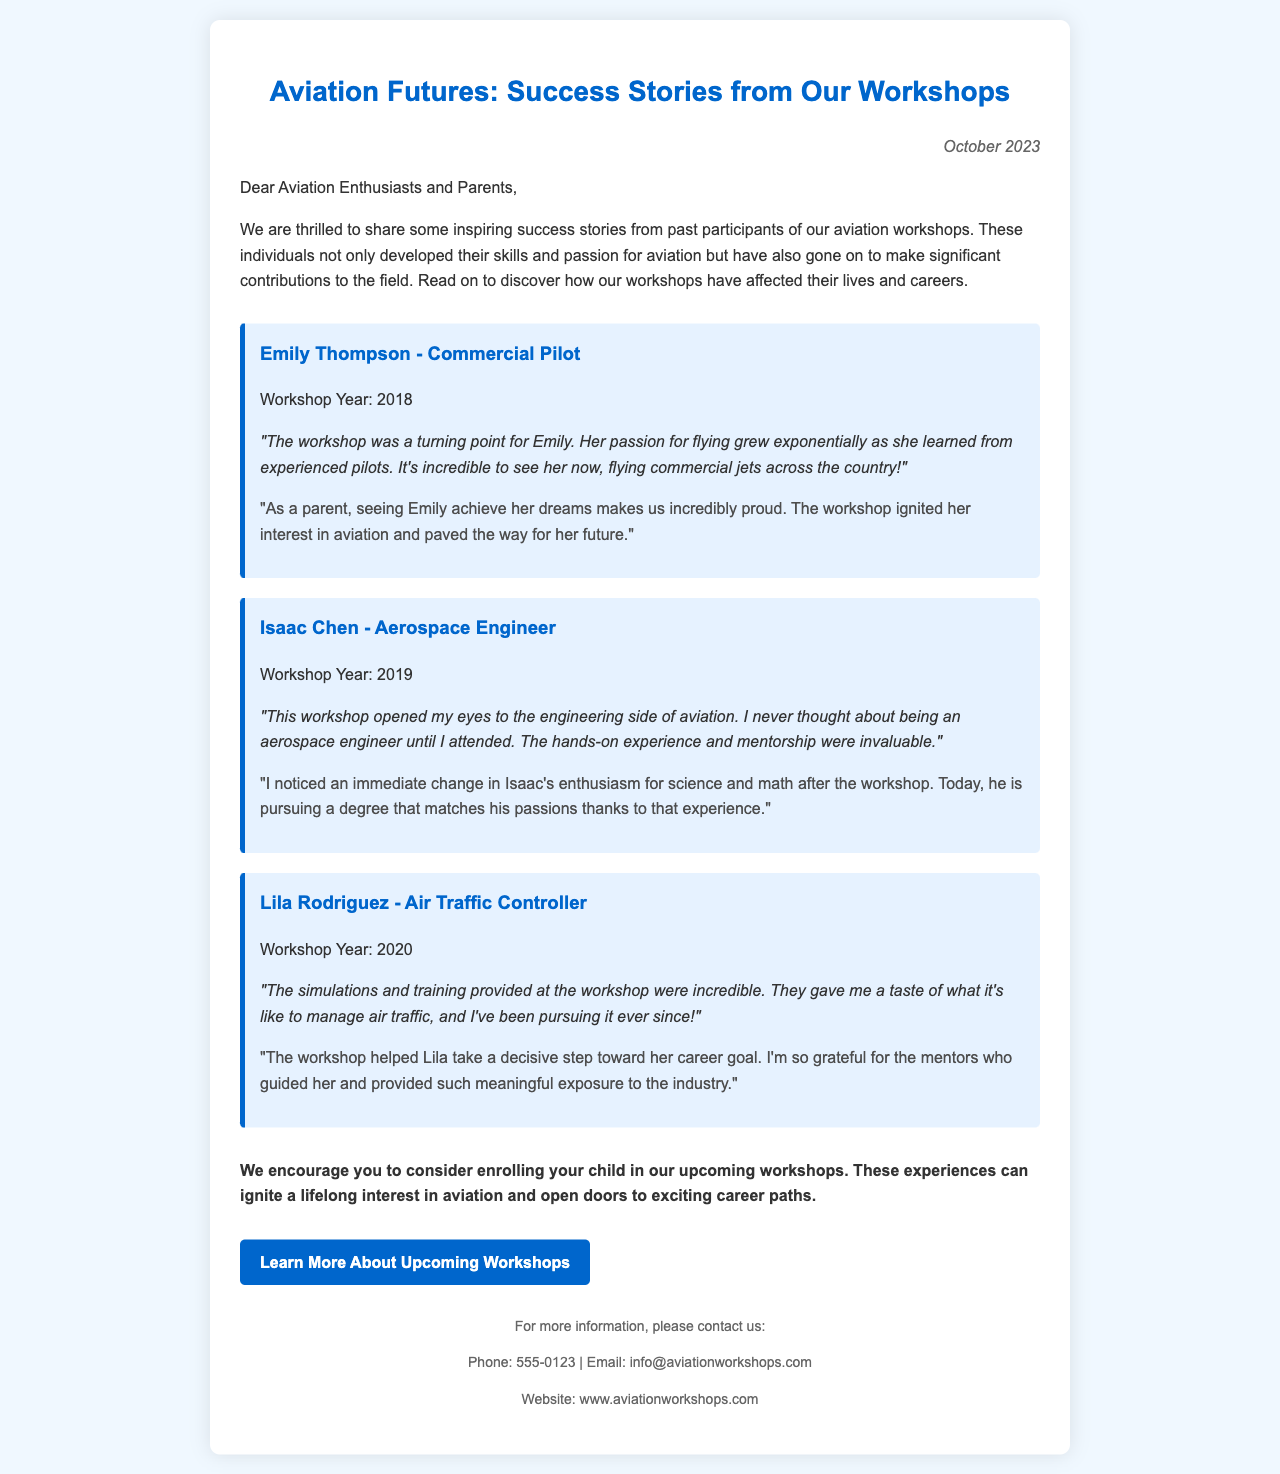What is the title of the newsletter? The title of the newsletter is prominently displayed at the top of the document.
Answer: Aviation Futures: Success Stories from Our Workshops When was the newsletter published? The publication date is mentioned in the top right section of the document.
Answer: October 2023 Who is a commercial pilot featured in the newsletter? The success story section provides names and careers of participants, specifically mentioning Emily Thompson.
Answer: Emily Thompson What workshop year did Isaac Chen attend? The document lists the workshop year next to each success story.
Answer: 2019 Which career does Lila Rodriguez pursue? The success stories detail the careers of past participants, including Lila Rodriguez's profession.
Answer: Air Traffic Controller What is the purpose of the newsletter? The introductory paragraph outlines the purpose, which is to share inspiring success stories.
Answer: To share inspiring success stories What did the workshop help Isaac Chen develop a passion for? The testimonial discusses how the workshop influenced Isaac's interest in a specific field.
Answer: Engineering How do the parents feel about their children's experiences in the workshop? The document contains testimonials from parents expressing pride and gratitude for the workshop's impact.
Answer: Proud and grateful What is a call-to-action mentioned in the newsletter? The concluding section has a specific action prompting readers to engage with future workshops.
Answer: Learn More About Upcoming Workshops 